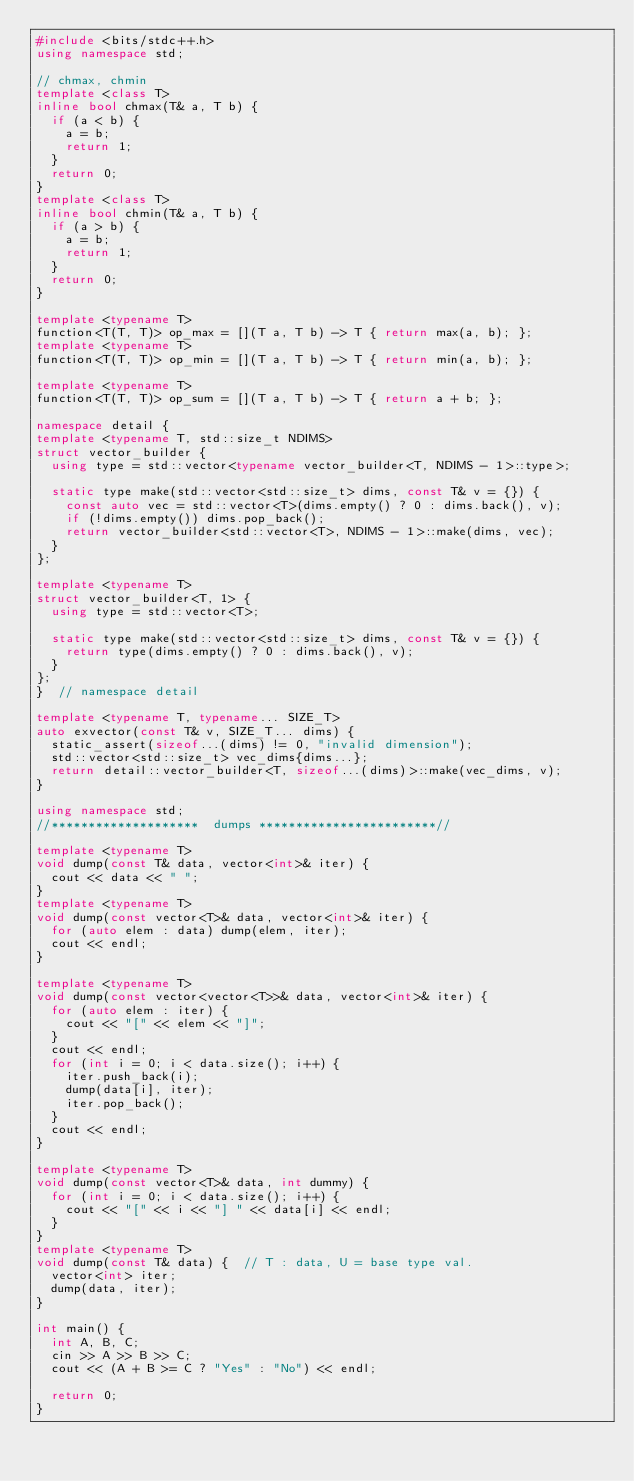<code> <loc_0><loc_0><loc_500><loc_500><_C++_>#include <bits/stdc++.h>
using namespace std;

// chmax, chmin
template <class T>
inline bool chmax(T& a, T b) {
  if (a < b) {
    a = b;
    return 1;
  }
  return 0;
}
template <class T>
inline bool chmin(T& a, T b) {
  if (a > b) {
    a = b;
    return 1;
  }
  return 0;
}

template <typename T>
function<T(T, T)> op_max = [](T a, T b) -> T { return max(a, b); };
template <typename T>
function<T(T, T)> op_min = [](T a, T b) -> T { return min(a, b); };

template <typename T>
function<T(T, T)> op_sum = [](T a, T b) -> T { return a + b; };

namespace detail {
template <typename T, std::size_t NDIMS>
struct vector_builder {
  using type = std::vector<typename vector_builder<T, NDIMS - 1>::type>;

  static type make(std::vector<std::size_t> dims, const T& v = {}) {
    const auto vec = std::vector<T>(dims.empty() ? 0 : dims.back(), v);
    if (!dims.empty()) dims.pop_back();
    return vector_builder<std::vector<T>, NDIMS - 1>::make(dims, vec);
  }
};

template <typename T>
struct vector_builder<T, 1> {
  using type = std::vector<T>;

  static type make(std::vector<std::size_t> dims, const T& v = {}) {
    return type(dims.empty() ? 0 : dims.back(), v);
  }
};
}  // namespace detail

template <typename T, typename... SIZE_T>
auto exvector(const T& v, SIZE_T... dims) {
  static_assert(sizeof...(dims) != 0, "invalid dimension");
  std::vector<std::size_t> vec_dims{dims...};
  return detail::vector_builder<T, sizeof...(dims)>::make(vec_dims, v);
}

using namespace std;
//********************  dumps ************************//

template <typename T>
void dump(const T& data, vector<int>& iter) {
  cout << data << " ";
}
template <typename T>
void dump(const vector<T>& data, vector<int>& iter) {
  for (auto elem : data) dump(elem, iter);
  cout << endl;
}

template <typename T>
void dump(const vector<vector<T>>& data, vector<int>& iter) {
  for (auto elem : iter) {
    cout << "[" << elem << "]";
  }
  cout << endl;
  for (int i = 0; i < data.size(); i++) {
    iter.push_back(i);
    dump(data[i], iter);
    iter.pop_back();
  }
  cout << endl;
}

template <typename T>
void dump(const vector<T>& data, int dummy) {
  for (int i = 0; i < data.size(); i++) {
    cout << "[" << i << "] " << data[i] << endl;
  }
}
template <typename T>
void dump(const T& data) {  // T : data, U = base type val.
  vector<int> iter;
  dump(data, iter);
}

int main() {
  int A, B, C;
  cin >> A >> B >> C;
  cout << (A + B >= C ? "Yes" : "No") << endl;

  return 0;
}</code> 